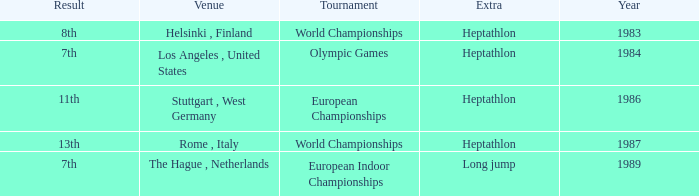How often are the Olympic games hosted? 1984.0. 